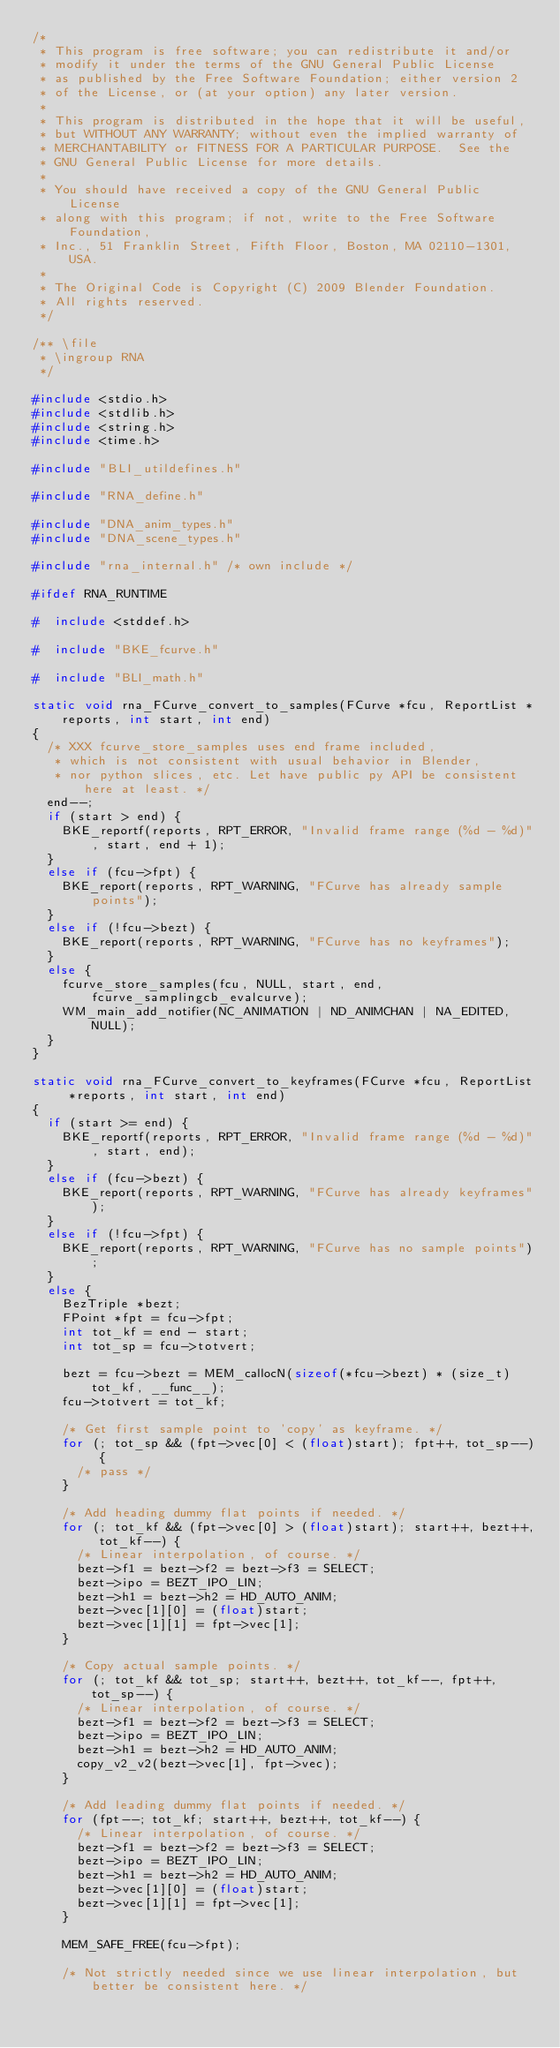<code> <loc_0><loc_0><loc_500><loc_500><_C_>/*
 * This program is free software; you can redistribute it and/or
 * modify it under the terms of the GNU General Public License
 * as published by the Free Software Foundation; either version 2
 * of the License, or (at your option) any later version.
 *
 * This program is distributed in the hope that it will be useful,
 * but WITHOUT ANY WARRANTY; without even the implied warranty of
 * MERCHANTABILITY or FITNESS FOR A PARTICULAR PURPOSE.  See the
 * GNU General Public License for more details.
 *
 * You should have received a copy of the GNU General Public License
 * along with this program; if not, write to the Free Software Foundation,
 * Inc., 51 Franklin Street, Fifth Floor, Boston, MA 02110-1301, USA.
 *
 * The Original Code is Copyright (C) 2009 Blender Foundation.
 * All rights reserved.
 */

/** \file
 * \ingroup RNA
 */

#include <stdio.h>
#include <stdlib.h>
#include <string.h>
#include <time.h>

#include "BLI_utildefines.h"

#include "RNA_define.h"

#include "DNA_anim_types.h"
#include "DNA_scene_types.h"

#include "rna_internal.h" /* own include */

#ifdef RNA_RUNTIME

#  include <stddef.h>

#  include "BKE_fcurve.h"

#  include "BLI_math.h"

static void rna_FCurve_convert_to_samples(FCurve *fcu, ReportList *reports, int start, int end)
{
  /* XXX fcurve_store_samples uses end frame included,
   * which is not consistent with usual behavior in Blender,
   * nor python slices, etc. Let have public py API be consistent here at least. */
  end--;
  if (start > end) {
    BKE_reportf(reports, RPT_ERROR, "Invalid frame range (%d - %d)", start, end + 1);
  }
  else if (fcu->fpt) {
    BKE_report(reports, RPT_WARNING, "FCurve has already sample points");
  }
  else if (!fcu->bezt) {
    BKE_report(reports, RPT_WARNING, "FCurve has no keyframes");
  }
  else {
    fcurve_store_samples(fcu, NULL, start, end, fcurve_samplingcb_evalcurve);
    WM_main_add_notifier(NC_ANIMATION | ND_ANIMCHAN | NA_EDITED, NULL);
  }
}

static void rna_FCurve_convert_to_keyframes(FCurve *fcu, ReportList *reports, int start, int end)
{
  if (start >= end) {
    BKE_reportf(reports, RPT_ERROR, "Invalid frame range (%d - %d)", start, end);
  }
  else if (fcu->bezt) {
    BKE_report(reports, RPT_WARNING, "FCurve has already keyframes");
  }
  else if (!fcu->fpt) {
    BKE_report(reports, RPT_WARNING, "FCurve has no sample points");
  }
  else {
    BezTriple *bezt;
    FPoint *fpt = fcu->fpt;
    int tot_kf = end - start;
    int tot_sp = fcu->totvert;

    bezt = fcu->bezt = MEM_callocN(sizeof(*fcu->bezt) * (size_t)tot_kf, __func__);
    fcu->totvert = tot_kf;

    /* Get first sample point to 'copy' as keyframe. */
    for (; tot_sp && (fpt->vec[0] < (float)start); fpt++, tot_sp--) {
      /* pass */
    }

    /* Add heading dummy flat points if needed. */
    for (; tot_kf && (fpt->vec[0] > (float)start); start++, bezt++, tot_kf--) {
      /* Linear interpolation, of course. */
      bezt->f1 = bezt->f2 = bezt->f3 = SELECT;
      bezt->ipo = BEZT_IPO_LIN;
      bezt->h1 = bezt->h2 = HD_AUTO_ANIM;
      bezt->vec[1][0] = (float)start;
      bezt->vec[1][1] = fpt->vec[1];
    }

    /* Copy actual sample points. */
    for (; tot_kf && tot_sp; start++, bezt++, tot_kf--, fpt++, tot_sp--) {
      /* Linear interpolation, of course. */
      bezt->f1 = bezt->f2 = bezt->f3 = SELECT;
      bezt->ipo = BEZT_IPO_LIN;
      bezt->h1 = bezt->h2 = HD_AUTO_ANIM;
      copy_v2_v2(bezt->vec[1], fpt->vec);
    }

    /* Add leading dummy flat points if needed. */
    for (fpt--; tot_kf; start++, bezt++, tot_kf--) {
      /* Linear interpolation, of course. */
      bezt->f1 = bezt->f2 = bezt->f3 = SELECT;
      bezt->ipo = BEZT_IPO_LIN;
      bezt->h1 = bezt->h2 = HD_AUTO_ANIM;
      bezt->vec[1][0] = (float)start;
      bezt->vec[1][1] = fpt->vec[1];
    }

    MEM_SAFE_FREE(fcu->fpt);

    /* Not strictly needed since we use linear interpolation, but better be consistent here. */</code> 